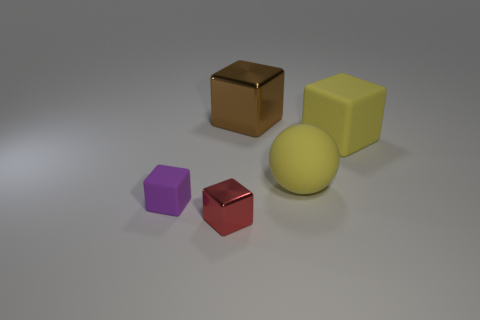Which object stands out the most to you and why? The yellow sphere stands out the most. Its round shape contrasts with the angular cubes, and its size is larger in comparison, drawing the eye. Additionally, its placement in the background creates a focal point through both scale and color contrast. 